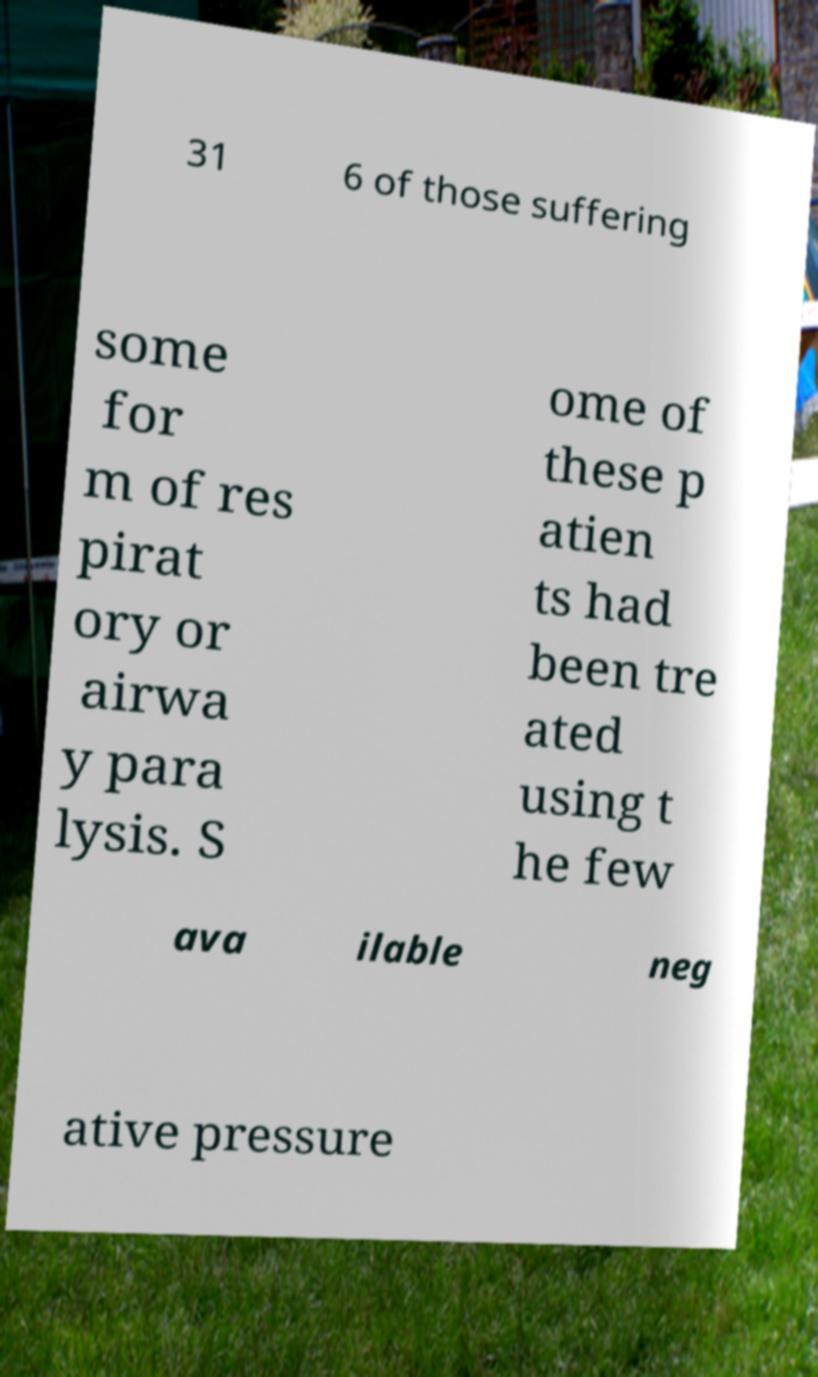Please read and relay the text visible in this image. What does it say? 31 6 of those suffering some for m of res pirat ory or airwa y para lysis. S ome of these p atien ts had been tre ated using t he few ava ilable neg ative pressure 